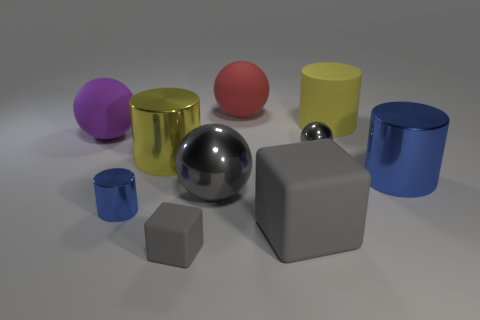Is the shape of the large purple matte object the same as the red thing? Yes, both the large purple object and the small red object are spheres. Despite the difference in size and texture, where the purple sphere has a matte finish and the red sphere appears smoother and shinier, they share the same geometric shape. 